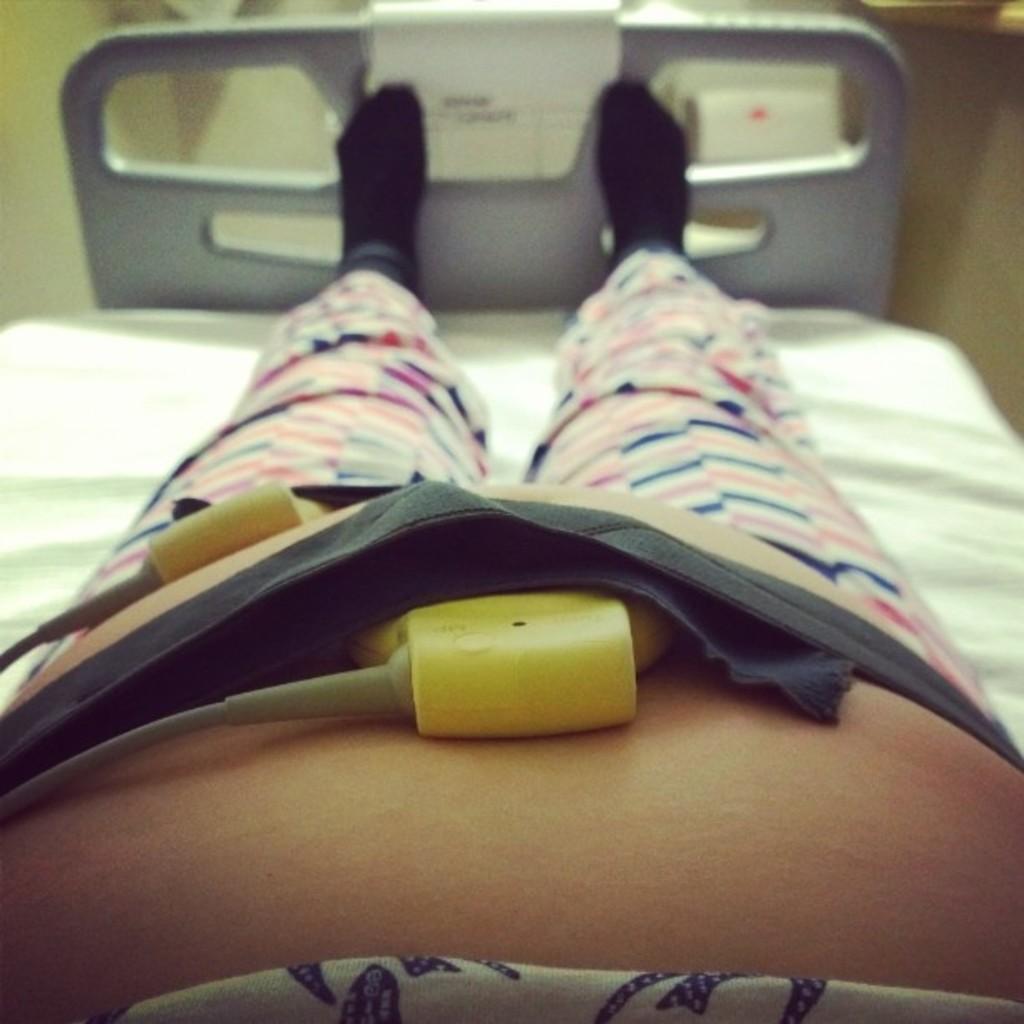Please provide a concise description of this image. In this image there is a person lying on the bed and there is an object on the person. At the back there is a paper on the bed and there is text on the paper. Behind the bed there is an object and there is a wall. 